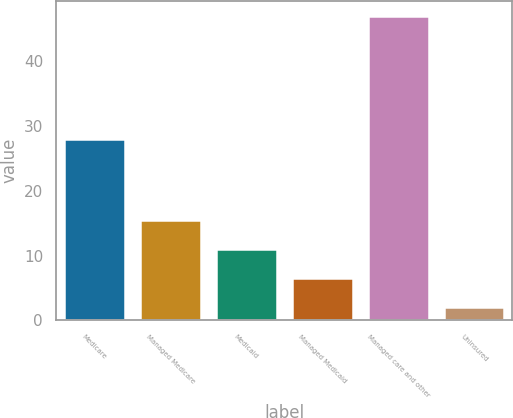Convert chart. <chart><loc_0><loc_0><loc_500><loc_500><bar_chart><fcel>Medicare<fcel>Managed Medicare<fcel>Medicaid<fcel>Managed Medicaid<fcel>Managed care and other<fcel>Uninsured<nl><fcel>28<fcel>15.5<fcel>11<fcel>6.5<fcel>47<fcel>2<nl></chart> 